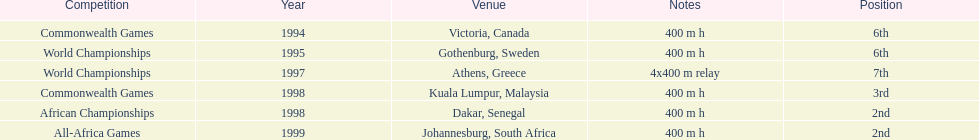In what years did ken harnden do better that 5th place? 1998, 1999. Give me the full table as a dictionary. {'header': ['Competition', 'Year', 'Venue', 'Notes', 'Position'], 'rows': [['Commonwealth Games', '1994', 'Victoria, Canada', '400 m h', '6th'], ['World Championships', '1995', 'Gothenburg, Sweden', '400 m h', '6th'], ['World Championships', '1997', 'Athens, Greece', '4x400 m relay', '7th'], ['Commonwealth Games', '1998', 'Kuala Lumpur, Malaysia', '400 m h', '3rd'], ['African Championships', '1998', 'Dakar, Senegal', '400 m h', '2nd'], ['All-Africa Games', '1999', 'Johannesburg, South Africa', '400 m h', '2nd']]} 